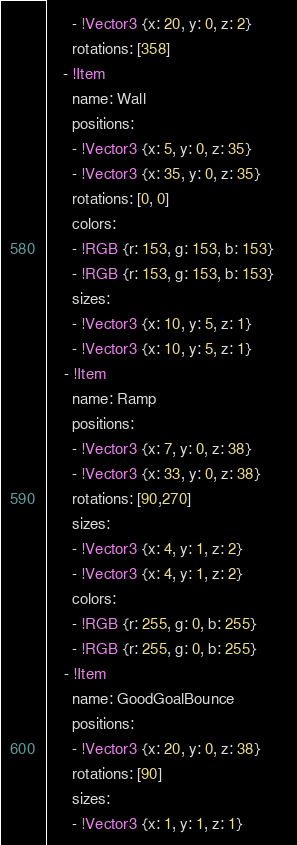Convert code to text. <code><loc_0><loc_0><loc_500><loc_500><_YAML_>      - !Vector3 {x: 20, y: 0, z: 2}
      rotations: [358]
    - !Item
      name: Wall
      positions:
      - !Vector3 {x: 5, y: 0, z: 35}
      - !Vector3 {x: 35, y: 0, z: 35}
      rotations: [0, 0]
      colors: 
      - !RGB {r: 153, g: 153, b: 153}
      - !RGB {r: 153, g: 153, b: 153}
      sizes:
      - !Vector3 {x: 10, y: 5, z: 1}
      - !Vector3 {x: 10, y: 5, z: 1}
    - !Item
      name: Ramp
      positions:
      - !Vector3 {x: 7, y: 0, z: 38}
      - !Vector3 {x: 33, y: 0, z: 38}
      rotations: [90,270]
      sizes:
      - !Vector3 {x: 4, y: 1, z: 2}
      - !Vector3 {x: 4, y: 1, z: 2}
      colors:
      - !RGB {r: 255, g: 0, b: 255}
      - !RGB {r: 255, g: 0, b: 255}
    - !Item
      name: GoodGoalBounce
      positions:
      - !Vector3 {x: 20, y: 0, z: 38}      
      rotations: [90]
      sizes:
      - !Vector3 {x: 1, y: 1, z: 1}</code> 